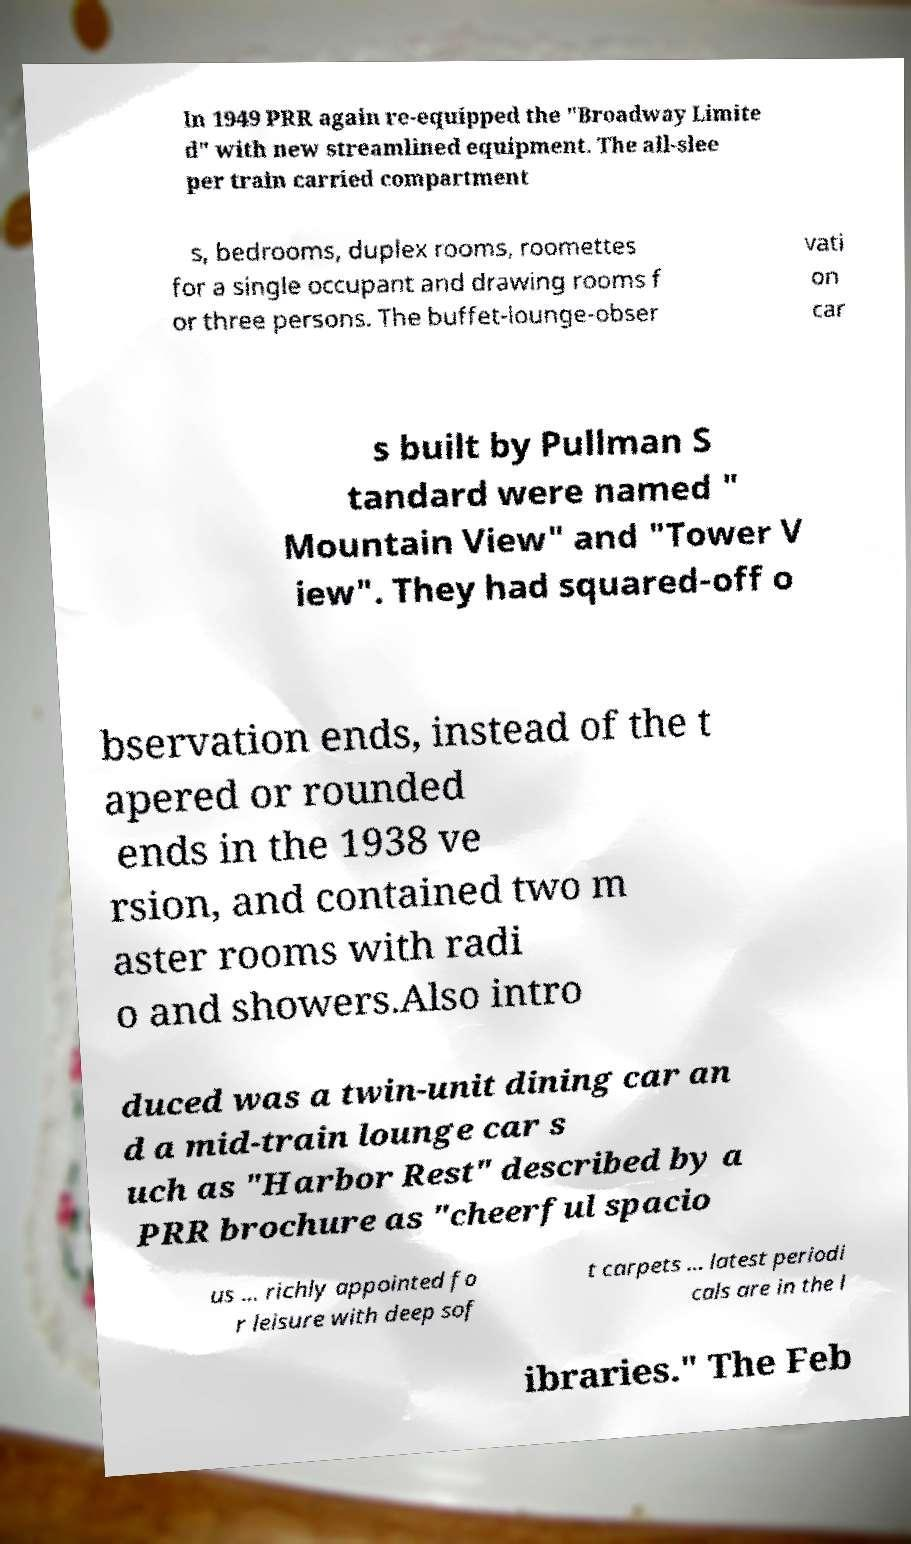Can you accurately transcribe the text from the provided image for me? In 1949 PRR again re-equipped the "Broadway Limite d" with new streamlined equipment. The all-slee per train carried compartment s, bedrooms, duplex rooms, roomettes for a single occupant and drawing rooms f or three persons. The buffet-lounge-obser vati on car s built by Pullman S tandard were named " Mountain View" and "Tower V iew". They had squared-off o bservation ends, instead of the t apered or rounded ends in the 1938 ve rsion, and contained two m aster rooms with radi o and showers.Also intro duced was a twin-unit dining car an d a mid-train lounge car s uch as "Harbor Rest" described by a PRR brochure as "cheerful spacio us ... richly appointed fo r leisure with deep sof t carpets ... latest periodi cals are in the l ibraries." The Feb 